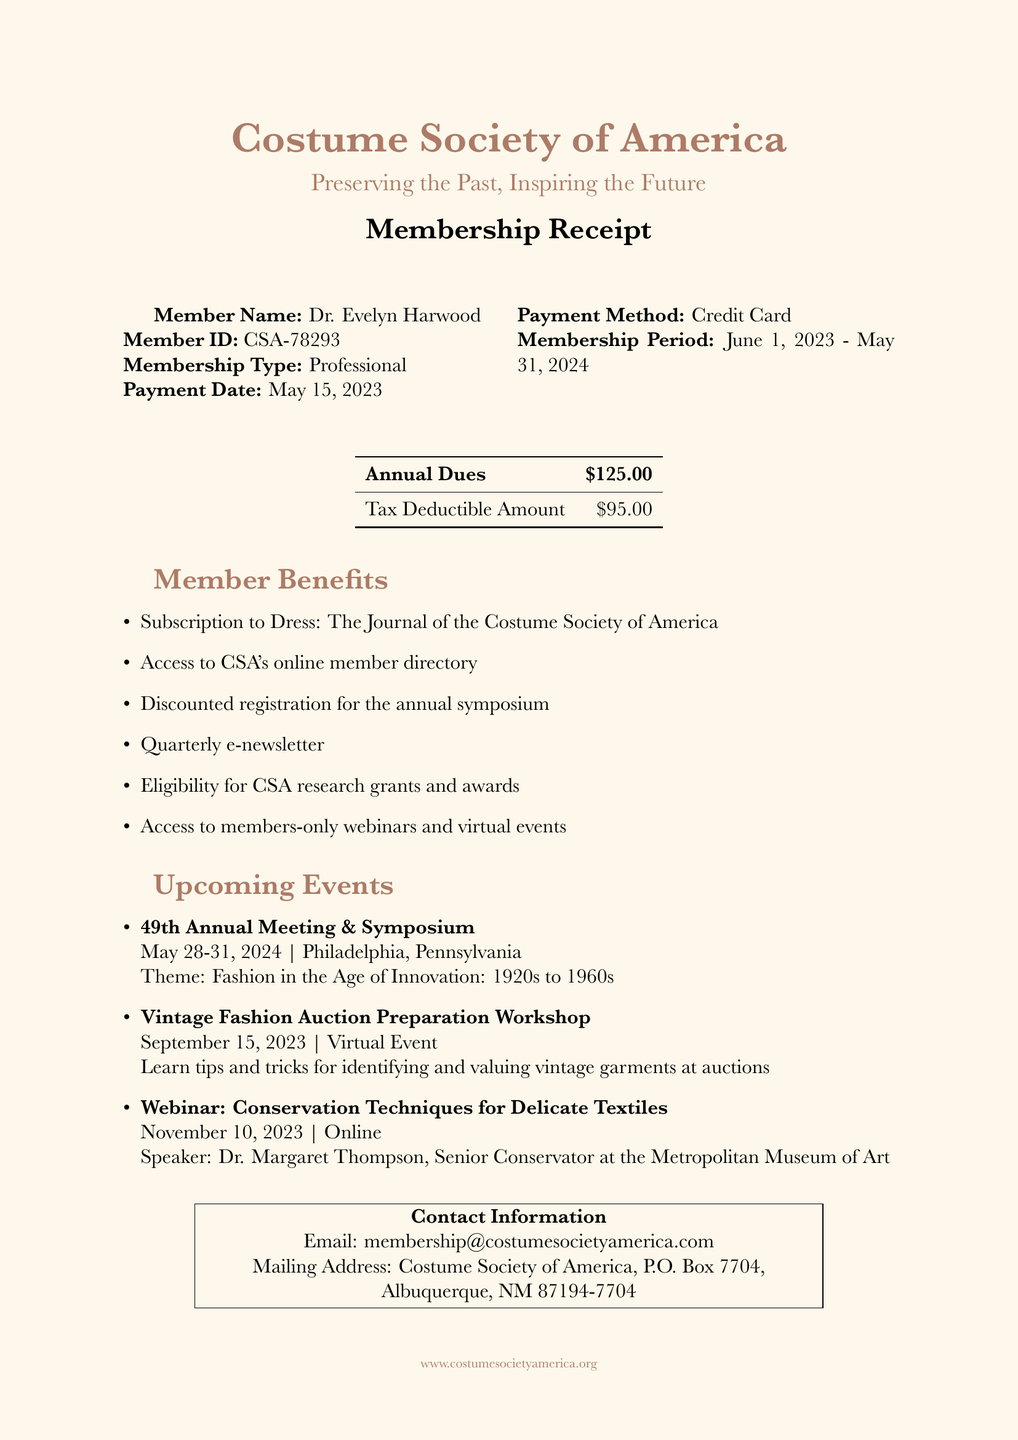What is the member's name? The member's name can be found at the top of the invoice, which states "Dr. Evelyn Harwood."
Answer: Dr. Evelyn Harwood What is the member's ID? The member ID is specified alongside the member's name, listed as "CSA-78293."
Answer: CSA-78293 What is the annual dues amount? The annual dues amount is detailed in the table on the invoice, which says "$125.00."
Answer: $125.00 What is the membership period? The membership period is located in the document, which indicates "June 1, 2023 - May 31, 2024."
Answer: June 1, 2023 - May 31, 2024 What is one of the member benefits? The member benefits list includes numerous advantages, one of which is "Subscription to Dress: The Journal of the Costume Society of America."
Answer: Subscription to Dress: The Journal of the Costume Society of America How many upcoming events are listed? The document includes a section for upcoming events, which enumerates three events.
Answer: 3 What is the theme of the 49th Annual Meeting & Symposium? The theme is specified under the upcoming events section, stating "Fashion in the Age of Innovation: 1920s to 1960s."
Answer: Fashion in the Age of Innovation: 1920s to 1960s What date is the Vintage Fashion Auction Preparation Workshop? The date can be found within the events section and is listed as "September 15, 2023."
Answer: September 15, 2023 Who is the speaker for the November 10, 2023 webinar? The speaker's name is mentioned in the webinar event details, which provides "Dr. Margaret Thompson, Senior Conservator at the Metropolitan Museum of Art."
Answer: Dr. Margaret Thompson, Senior Conservator at the Metropolitan Museum of Art 